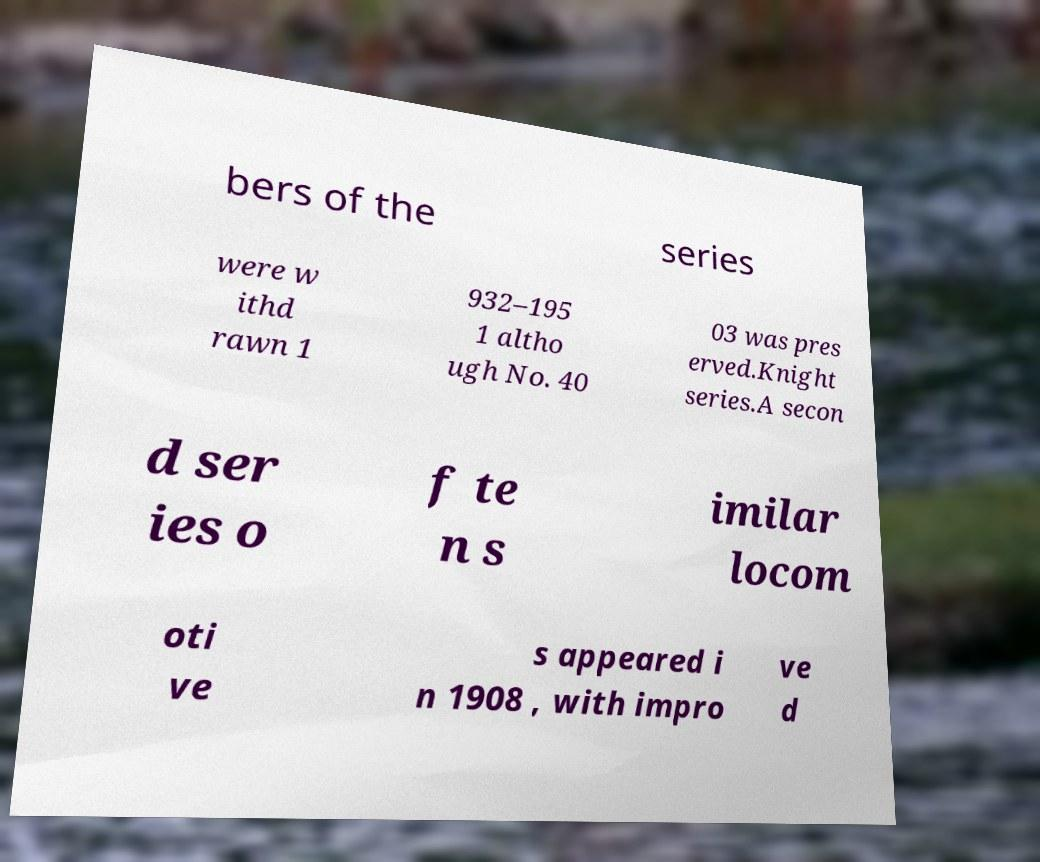Could you extract and type out the text from this image? bers of the series were w ithd rawn 1 932–195 1 altho ugh No. 40 03 was pres erved.Knight series.A secon d ser ies o f te n s imilar locom oti ve s appeared i n 1908 , with impro ve d 